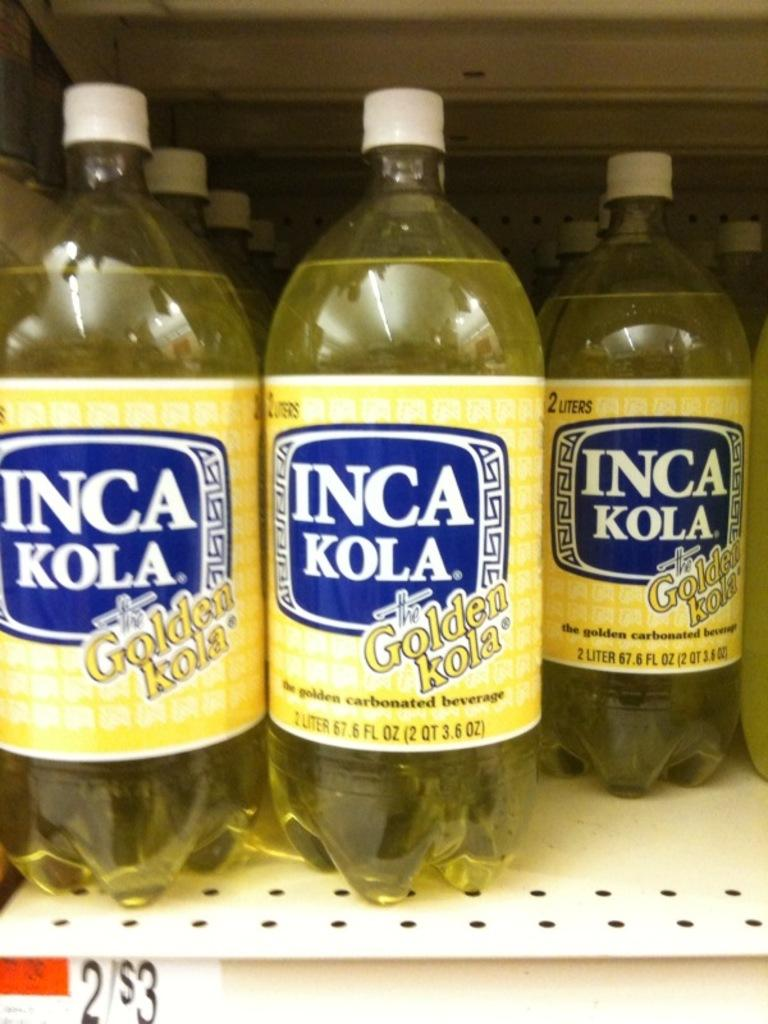<image>
Present a compact description of the photo's key features. Bottles of Inca Kola Golden Kola are on a shelf. 